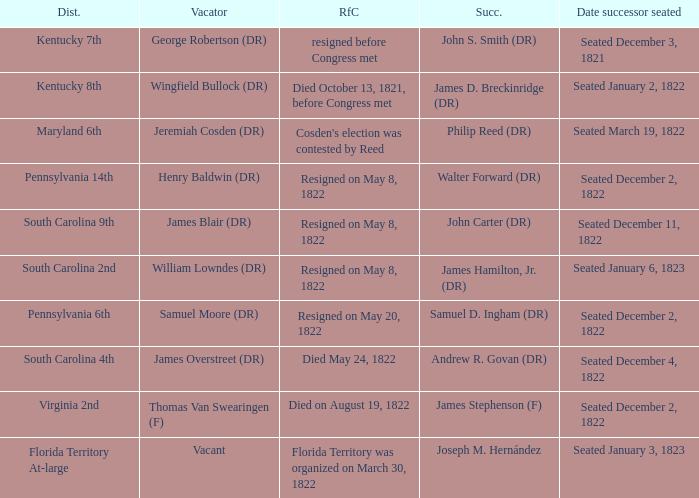What is the reason for change when maryland 6th is the district?  Cosden's election was contested by Reed. 